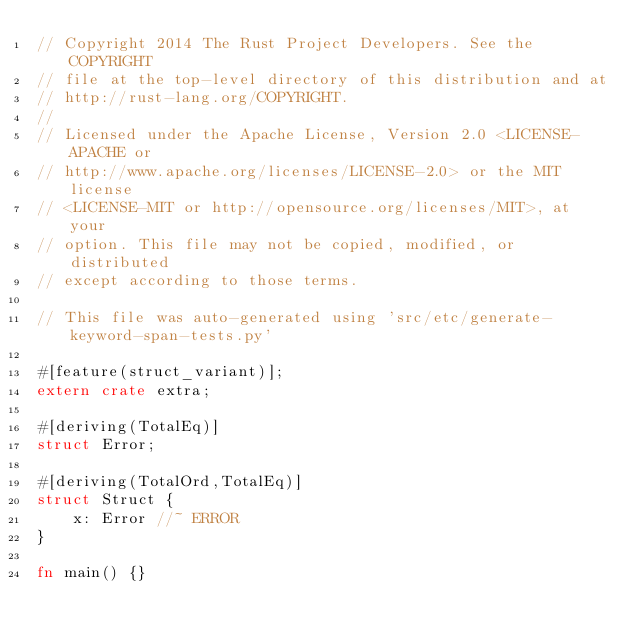<code> <loc_0><loc_0><loc_500><loc_500><_Rust_>// Copyright 2014 The Rust Project Developers. See the COPYRIGHT
// file at the top-level directory of this distribution and at
// http://rust-lang.org/COPYRIGHT.
//
// Licensed under the Apache License, Version 2.0 <LICENSE-APACHE or
// http://www.apache.org/licenses/LICENSE-2.0> or the MIT license
// <LICENSE-MIT or http://opensource.org/licenses/MIT>, at your
// option. This file may not be copied, modified, or distributed
// except according to those terms.

// This file was auto-generated using 'src/etc/generate-keyword-span-tests.py'

#[feature(struct_variant)];
extern crate extra;

#[deriving(TotalEq)]
struct Error;

#[deriving(TotalOrd,TotalEq)]
struct Struct {
    x: Error //~ ERROR
}

fn main() {}
</code> 